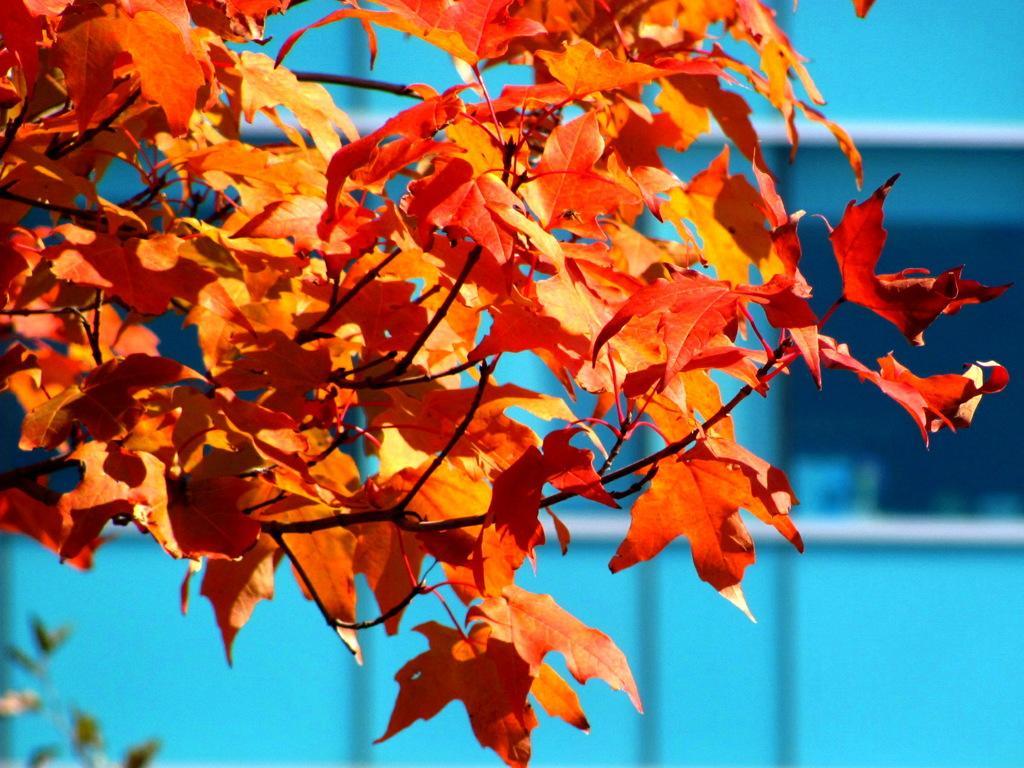Please provide a concise description of this image. In this image there is tree with orange and red color flowers, and there is blue background. 